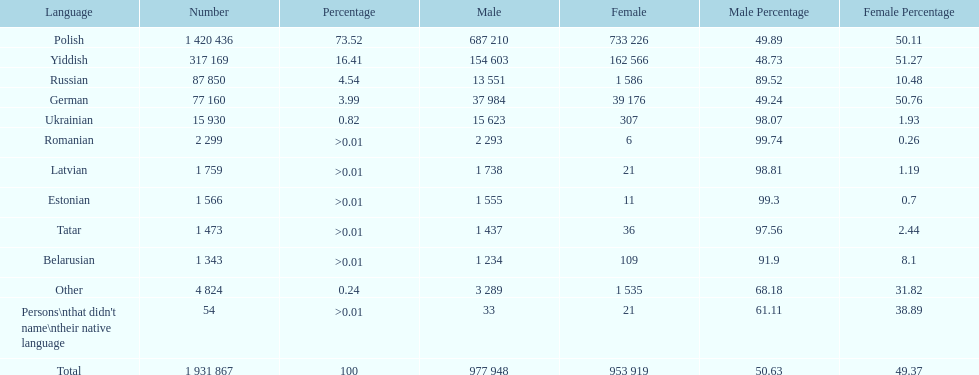Is german above or below russia in the number of people who speak that language? Below. 